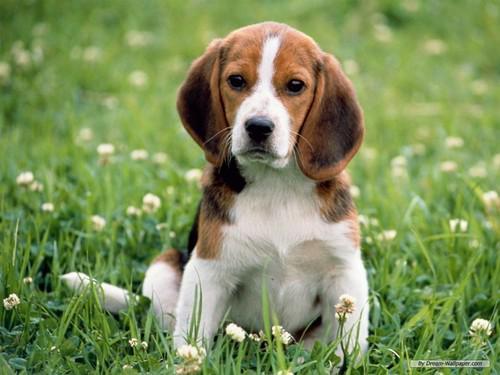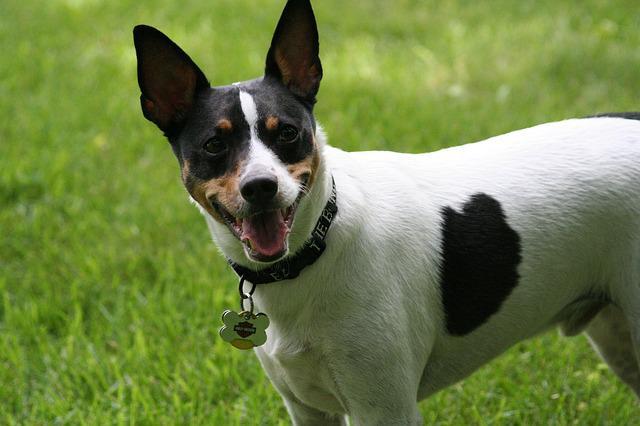The first image is the image on the left, the second image is the image on the right. Examine the images to the left and right. Is the description "An image contains an animal that is not a floppy-eared beagle." accurate? Answer yes or no. Yes. 